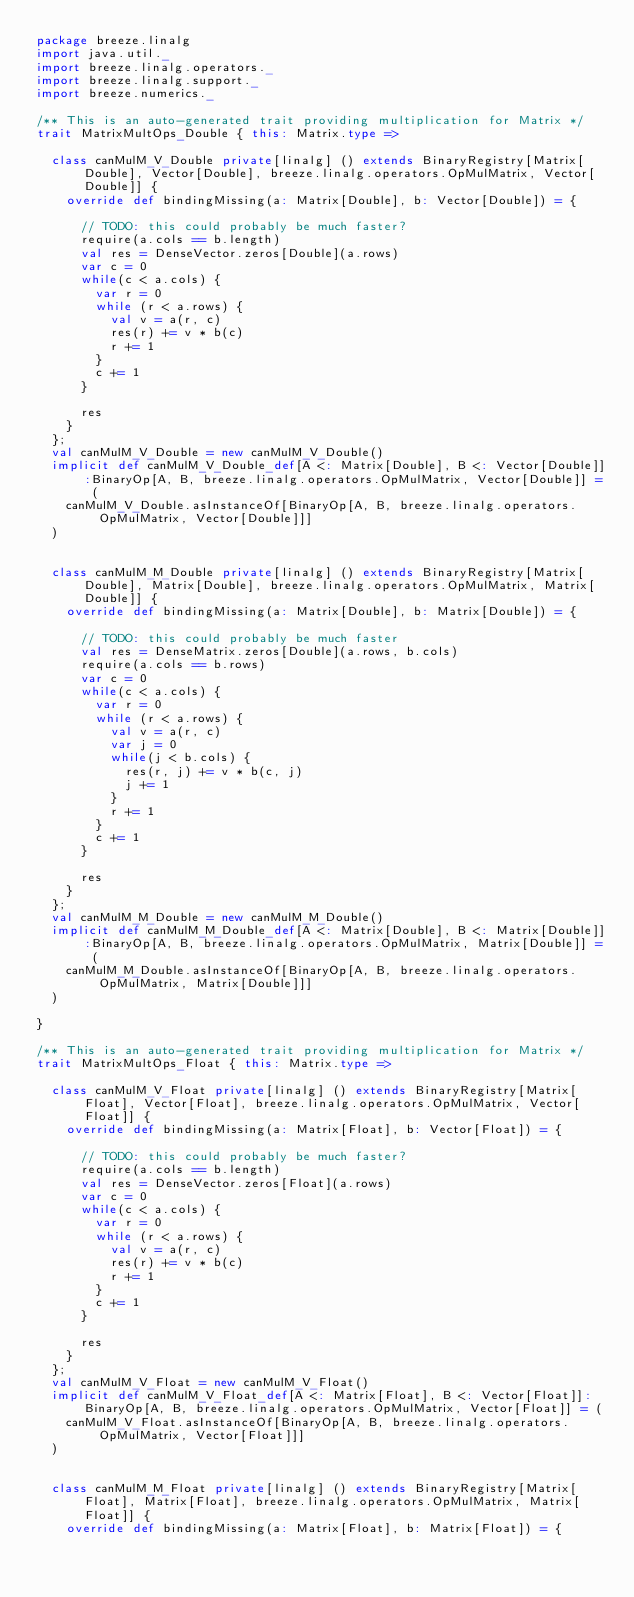Convert code to text. <code><loc_0><loc_0><loc_500><loc_500><_Scala_>package breeze.linalg
import java.util._
import breeze.linalg.operators._
import breeze.linalg.support._
import breeze.numerics._

/** This is an auto-generated trait providing multiplication for Matrix */
trait MatrixMultOps_Double { this: Matrix.type =>

  class canMulM_V_Double private[linalg] () extends BinaryRegistry[Matrix[Double], Vector[Double], breeze.linalg.operators.OpMulMatrix, Vector[Double]] {
    override def bindingMissing(a: Matrix[Double], b: Vector[Double]) = {
      
      // TODO: this could probably be much faster?
      require(a.cols == b.length)
      val res = DenseVector.zeros[Double](a.rows)
      var c = 0
      while(c < a.cols) {
        var r = 0
        while (r < a.rows) {
          val v = a(r, c)
          res(r) += v * b(c)
          r += 1
        }
        c += 1
      }

      res                                                               
    }
  };
  val canMulM_V_Double = new canMulM_V_Double()
  implicit def canMulM_V_Double_def[A <: Matrix[Double], B <: Vector[Double]]:BinaryOp[A, B, breeze.linalg.operators.OpMulMatrix, Vector[Double]] = (
    canMulM_V_Double.asInstanceOf[BinaryOp[A, B, breeze.linalg.operators.OpMulMatrix, Vector[Double]]]
  )
    

  class canMulM_M_Double private[linalg] () extends BinaryRegistry[Matrix[Double], Matrix[Double], breeze.linalg.operators.OpMulMatrix, Matrix[Double]] {
    override def bindingMissing(a: Matrix[Double], b: Matrix[Double]) = {
      
      // TODO: this could probably be much faster
      val res = DenseMatrix.zeros[Double](a.rows, b.cols)
      require(a.cols == b.rows)
      var c = 0
      while(c < a.cols) {
        var r = 0
        while (r < a.rows) {
          val v = a(r, c)
          var j = 0
          while(j < b.cols) {
            res(r, j) += v * b(c, j)
            j += 1
          }
          r += 1
        }
        c += 1
      }

      res                                                               
    }
  };
  val canMulM_M_Double = new canMulM_M_Double()
  implicit def canMulM_M_Double_def[A <: Matrix[Double], B <: Matrix[Double]]:BinaryOp[A, B, breeze.linalg.operators.OpMulMatrix, Matrix[Double]] = (
    canMulM_M_Double.asInstanceOf[BinaryOp[A, B, breeze.linalg.operators.OpMulMatrix, Matrix[Double]]]
  )
    
}

/** This is an auto-generated trait providing multiplication for Matrix */
trait MatrixMultOps_Float { this: Matrix.type =>

  class canMulM_V_Float private[linalg] () extends BinaryRegistry[Matrix[Float], Vector[Float], breeze.linalg.operators.OpMulMatrix, Vector[Float]] {
    override def bindingMissing(a: Matrix[Float], b: Vector[Float]) = {
      
      // TODO: this could probably be much faster?
      require(a.cols == b.length)
      val res = DenseVector.zeros[Float](a.rows)
      var c = 0
      while(c < a.cols) {
        var r = 0
        while (r < a.rows) {
          val v = a(r, c)
          res(r) += v * b(c)
          r += 1
        }
        c += 1
      }

      res                                                               
    }
  };
  val canMulM_V_Float = new canMulM_V_Float()
  implicit def canMulM_V_Float_def[A <: Matrix[Float], B <: Vector[Float]]:BinaryOp[A, B, breeze.linalg.operators.OpMulMatrix, Vector[Float]] = (
    canMulM_V_Float.asInstanceOf[BinaryOp[A, B, breeze.linalg.operators.OpMulMatrix, Vector[Float]]]
  )
    

  class canMulM_M_Float private[linalg] () extends BinaryRegistry[Matrix[Float], Matrix[Float], breeze.linalg.operators.OpMulMatrix, Matrix[Float]] {
    override def bindingMissing(a: Matrix[Float], b: Matrix[Float]) = {</code> 